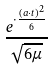<formula> <loc_0><loc_0><loc_500><loc_500>\frac { e ^ { \cdot \frac { ( a \cdot t ) ^ { 2 } } { 6 } } } { \sqrt { 6 \mu } }</formula> 